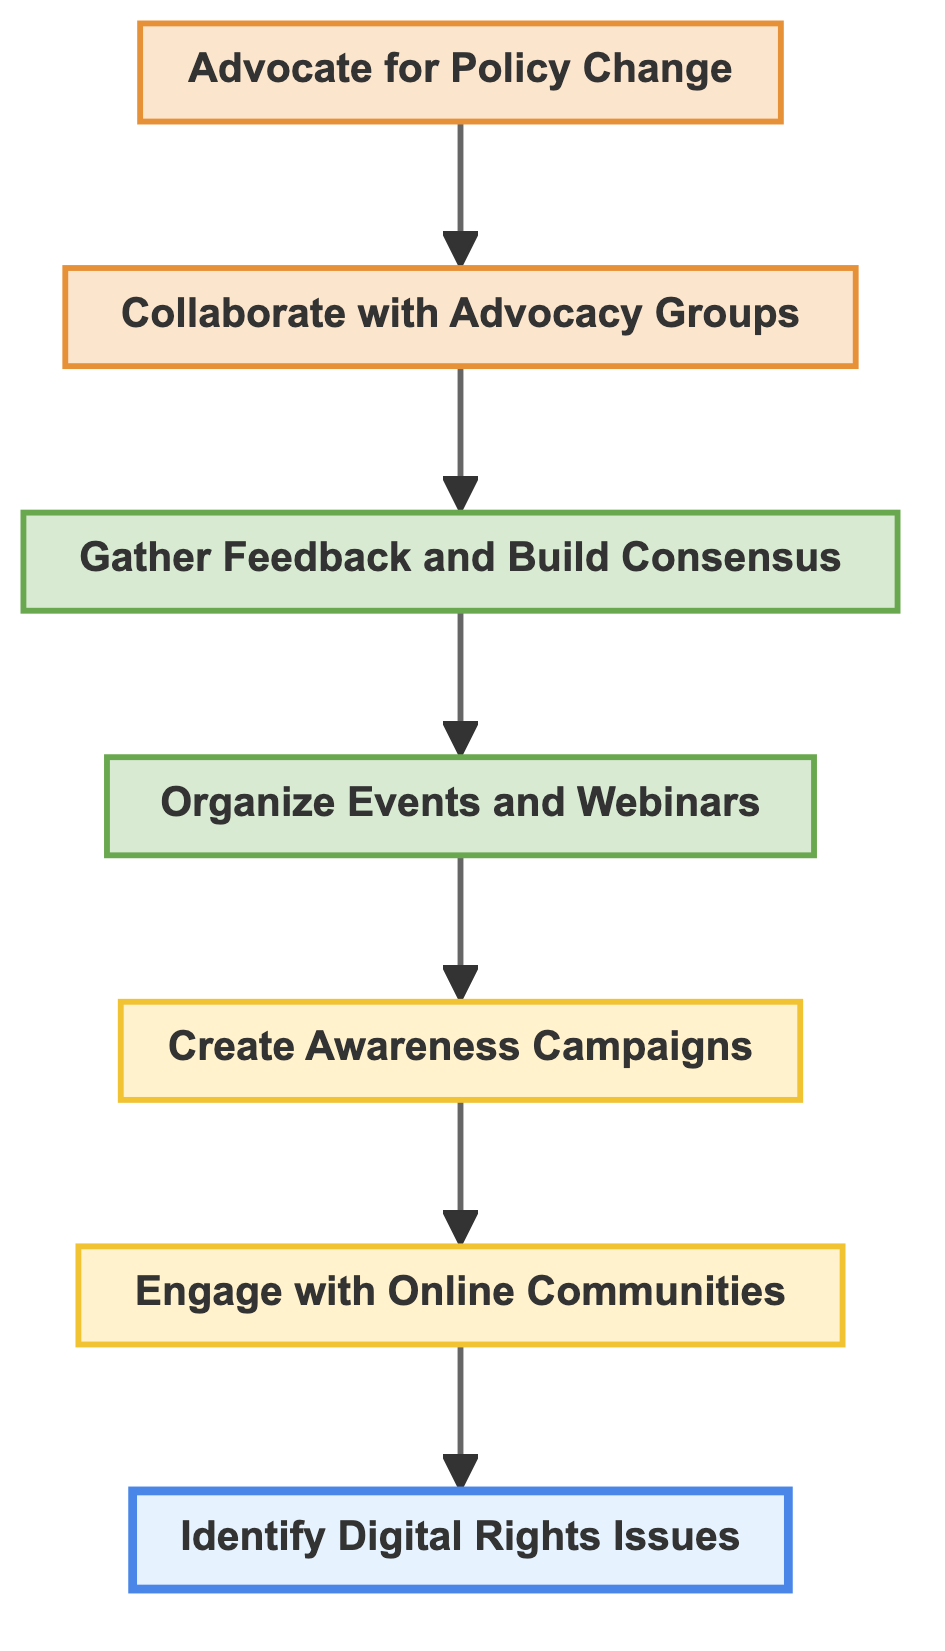What is the first step in the flow chart? The flow chart begins with the node labeled "Identify Digital Rights Issues," which is the first element in the bottom-up structure.
Answer: Identify Digital Rights Issues How many steps are there in the flow chart? The flow chart consists of a total of seven steps, each representing an essential part of the process for community engagement in digital rights advocacy.
Answer: Seven Which node leads to "Collaborate with Advocacy Groups"? The node "Gather Feedback and Build Consensus" directly leads to "Collaborate with Advocacy Groups," indicating that gathering feedback is a precursor to collaboration.
Answer: Gather Feedback and Build Consensus What is the last step in the flow chart? "Advocate for Policy Change" is the final step in the flow chart, representing the ultimate goal of the community engagement process.
Answer: Advocate for Policy Change What type of campaigns are created as per the flow chart? The flow chart specifies that "Create Awareness Campaigns" is focused on developing targeted campaigns using various media to inform the community about digital rights issues.
Answer: Awareness Campaigns Which step involves hosting online events? The process of hosting online events is outlined in the node "Organize Events and Webinars," indicating this is where community interaction is facilitated.
Answer: Organize Events and Webinars What is the relationship between "Engage with Online Communities" and "Identify Digital Rights Issues"? "Engage with Online Communities" follows the process of "Identify Digital Rights Issues," suggesting that engaging with communities comes after recognizing the pertinent issues.
Answer: Engage with Online Communities follows Identify Digital Rights Issues What is the purpose of gathering feedback in the flow chart? The purpose of gathering feedback is to refine advocacy strategies and campaign focus, as indicated in the step "Gather Feedback and Build Consensus."
Answer: Refine advocacy strategies and campaign focus 